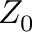<formula> <loc_0><loc_0><loc_500><loc_500>Z _ { 0 }</formula> 